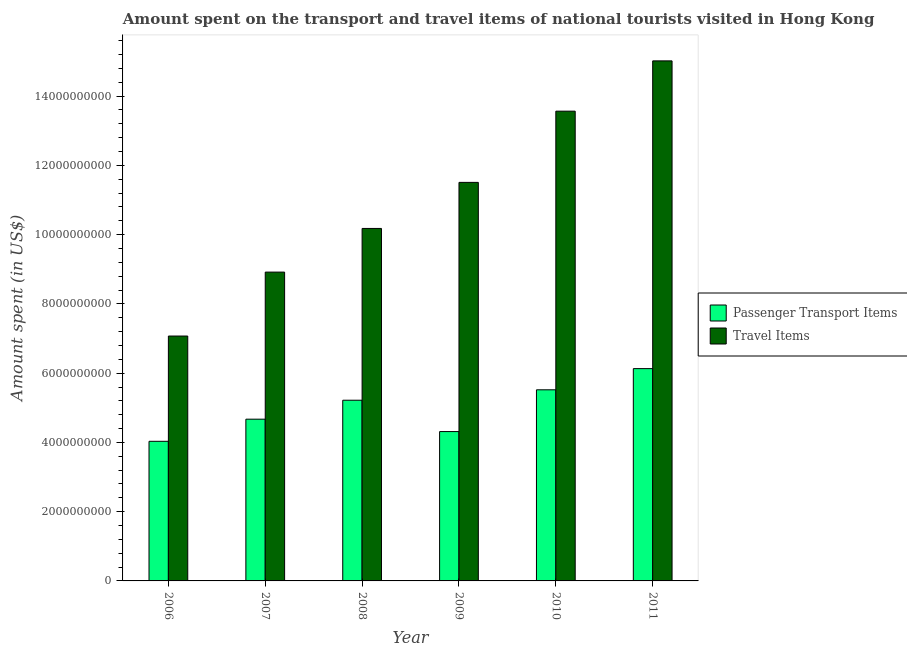Are the number of bars per tick equal to the number of legend labels?
Offer a terse response. Yes. What is the label of the 2nd group of bars from the left?
Make the answer very short. 2007. In how many cases, is the number of bars for a given year not equal to the number of legend labels?
Ensure brevity in your answer.  0. What is the amount spent on passenger transport items in 2007?
Provide a succinct answer. 4.67e+09. Across all years, what is the maximum amount spent in travel items?
Provide a succinct answer. 1.50e+1. Across all years, what is the minimum amount spent in travel items?
Provide a succinct answer. 7.07e+09. What is the total amount spent in travel items in the graph?
Your answer should be very brief. 6.63e+1. What is the difference between the amount spent in travel items in 2008 and that in 2011?
Ensure brevity in your answer.  -4.84e+09. What is the difference between the amount spent on passenger transport items in 2006 and the amount spent in travel items in 2008?
Keep it short and to the point. -1.19e+09. What is the average amount spent on passenger transport items per year?
Your answer should be compact. 4.98e+09. In how many years, is the amount spent in travel items greater than 11600000000 US$?
Your answer should be very brief. 2. What is the ratio of the amount spent in travel items in 2009 to that in 2011?
Offer a terse response. 0.77. What is the difference between the highest and the second highest amount spent on passenger transport items?
Your response must be concise. 6.12e+08. What is the difference between the highest and the lowest amount spent on passenger transport items?
Keep it short and to the point. 2.10e+09. What does the 1st bar from the left in 2009 represents?
Provide a succinct answer. Passenger Transport Items. What does the 2nd bar from the right in 2007 represents?
Offer a very short reply. Passenger Transport Items. Are all the bars in the graph horizontal?
Keep it short and to the point. No. How many years are there in the graph?
Keep it short and to the point. 6. Does the graph contain any zero values?
Keep it short and to the point. No. Does the graph contain grids?
Provide a succinct answer. No. Where does the legend appear in the graph?
Give a very brief answer. Center right. How are the legend labels stacked?
Your answer should be very brief. Vertical. What is the title of the graph?
Your answer should be very brief. Amount spent on the transport and travel items of national tourists visited in Hong Kong. Does "Primary school" appear as one of the legend labels in the graph?
Your answer should be compact. No. What is the label or title of the X-axis?
Make the answer very short. Year. What is the label or title of the Y-axis?
Your answer should be very brief. Amount spent (in US$). What is the Amount spent (in US$) of Passenger Transport Items in 2006?
Your response must be concise. 4.03e+09. What is the Amount spent (in US$) of Travel Items in 2006?
Make the answer very short. 7.07e+09. What is the Amount spent (in US$) of Passenger Transport Items in 2007?
Offer a very short reply. 4.67e+09. What is the Amount spent (in US$) of Travel Items in 2007?
Keep it short and to the point. 8.92e+09. What is the Amount spent (in US$) in Passenger Transport Items in 2008?
Offer a terse response. 5.22e+09. What is the Amount spent (in US$) of Travel Items in 2008?
Your answer should be very brief. 1.02e+1. What is the Amount spent (in US$) in Passenger Transport Items in 2009?
Your response must be concise. 4.31e+09. What is the Amount spent (in US$) in Travel Items in 2009?
Provide a short and direct response. 1.15e+1. What is the Amount spent (in US$) of Passenger Transport Items in 2010?
Give a very brief answer. 5.52e+09. What is the Amount spent (in US$) in Travel Items in 2010?
Your response must be concise. 1.36e+1. What is the Amount spent (in US$) in Passenger Transport Items in 2011?
Offer a terse response. 6.13e+09. What is the Amount spent (in US$) in Travel Items in 2011?
Your answer should be compact. 1.50e+1. Across all years, what is the maximum Amount spent (in US$) in Passenger Transport Items?
Provide a succinct answer. 6.13e+09. Across all years, what is the maximum Amount spent (in US$) in Travel Items?
Offer a terse response. 1.50e+1. Across all years, what is the minimum Amount spent (in US$) of Passenger Transport Items?
Offer a terse response. 4.03e+09. Across all years, what is the minimum Amount spent (in US$) of Travel Items?
Offer a terse response. 7.07e+09. What is the total Amount spent (in US$) in Passenger Transport Items in the graph?
Your response must be concise. 2.99e+1. What is the total Amount spent (in US$) in Travel Items in the graph?
Give a very brief answer. 6.63e+1. What is the difference between the Amount spent (in US$) of Passenger Transport Items in 2006 and that in 2007?
Offer a terse response. -6.39e+08. What is the difference between the Amount spent (in US$) of Travel Items in 2006 and that in 2007?
Provide a short and direct response. -1.85e+09. What is the difference between the Amount spent (in US$) of Passenger Transport Items in 2006 and that in 2008?
Give a very brief answer. -1.19e+09. What is the difference between the Amount spent (in US$) in Travel Items in 2006 and that in 2008?
Offer a terse response. -3.11e+09. What is the difference between the Amount spent (in US$) in Passenger Transport Items in 2006 and that in 2009?
Give a very brief answer. -2.81e+08. What is the difference between the Amount spent (in US$) in Travel Items in 2006 and that in 2009?
Keep it short and to the point. -4.44e+09. What is the difference between the Amount spent (in US$) of Passenger Transport Items in 2006 and that in 2010?
Keep it short and to the point. -1.49e+09. What is the difference between the Amount spent (in US$) of Travel Items in 2006 and that in 2010?
Give a very brief answer. -6.49e+09. What is the difference between the Amount spent (in US$) of Passenger Transport Items in 2006 and that in 2011?
Keep it short and to the point. -2.10e+09. What is the difference between the Amount spent (in US$) of Travel Items in 2006 and that in 2011?
Provide a succinct answer. -7.95e+09. What is the difference between the Amount spent (in US$) of Passenger Transport Items in 2007 and that in 2008?
Your response must be concise. -5.47e+08. What is the difference between the Amount spent (in US$) in Travel Items in 2007 and that in 2008?
Keep it short and to the point. -1.26e+09. What is the difference between the Amount spent (in US$) of Passenger Transport Items in 2007 and that in 2009?
Your response must be concise. 3.58e+08. What is the difference between the Amount spent (in US$) in Travel Items in 2007 and that in 2009?
Your answer should be very brief. -2.59e+09. What is the difference between the Amount spent (in US$) in Passenger Transport Items in 2007 and that in 2010?
Give a very brief answer. -8.48e+08. What is the difference between the Amount spent (in US$) in Travel Items in 2007 and that in 2010?
Your answer should be very brief. -4.65e+09. What is the difference between the Amount spent (in US$) in Passenger Transport Items in 2007 and that in 2011?
Ensure brevity in your answer.  -1.46e+09. What is the difference between the Amount spent (in US$) in Travel Items in 2007 and that in 2011?
Your answer should be very brief. -6.10e+09. What is the difference between the Amount spent (in US$) in Passenger Transport Items in 2008 and that in 2009?
Offer a terse response. 9.05e+08. What is the difference between the Amount spent (in US$) in Travel Items in 2008 and that in 2009?
Provide a succinct answer. -1.33e+09. What is the difference between the Amount spent (in US$) in Passenger Transport Items in 2008 and that in 2010?
Provide a short and direct response. -3.01e+08. What is the difference between the Amount spent (in US$) of Travel Items in 2008 and that in 2010?
Your answer should be very brief. -3.39e+09. What is the difference between the Amount spent (in US$) of Passenger Transport Items in 2008 and that in 2011?
Ensure brevity in your answer.  -9.13e+08. What is the difference between the Amount spent (in US$) of Travel Items in 2008 and that in 2011?
Ensure brevity in your answer.  -4.84e+09. What is the difference between the Amount spent (in US$) of Passenger Transport Items in 2009 and that in 2010?
Give a very brief answer. -1.21e+09. What is the difference between the Amount spent (in US$) in Travel Items in 2009 and that in 2010?
Give a very brief answer. -2.06e+09. What is the difference between the Amount spent (in US$) in Passenger Transport Items in 2009 and that in 2011?
Provide a succinct answer. -1.82e+09. What is the difference between the Amount spent (in US$) of Travel Items in 2009 and that in 2011?
Give a very brief answer. -3.51e+09. What is the difference between the Amount spent (in US$) of Passenger Transport Items in 2010 and that in 2011?
Offer a terse response. -6.12e+08. What is the difference between the Amount spent (in US$) of Travel Items in 2010 and that in 2011?
Provide a succinct answer. -1.45e+09. What is the difference between the Amount spent (in US$) in Passenger Transport Items in 2006 and the Amount spent (in US$) in Travel Items in 2007?
Offer a terse response. -4.89e+09. What is the difference between the Amount spent (in US$) in Passenger Transport Items in 2006 and the Amount spent (in US$) in Travel Items in 2008?
Your answer should be very brief. -6.15e+09. What is the difference between the Amount spent (in US$) of Passenger Transport Items in 2006 and the Amount spent (in US$) of Travel Items in 2009?
Your answer should be very brief. -7.48e+09. What is the difference between the Amount spent (in US$) of Passenger Transport Items in 2006 and the Amount spent (in US$) of Travel Items in 2010?
Ensure brevity in your answer.  -9.53e+09. What is the difference between the Amount spent (in US$) in Passenger Transport Items in 2006 and the Amount spent (in US$) in Travel Items in 2011?
Offer a terse response. -1.10e+1. What is the difference between the Amount spent (in US$) in Passenger Transport Items in 2007 and the Amount spent (in US$) in Travel Items in 2008?
Provide a short and direct response. -5.51e+09. What is the difference between the Amount spent (in US$) of Passenger Transport Items in 2007 and the Amount spent (in US$) of Travel Items in 2009?
Provide a short and direct response. -6.84e+09. What is the difference between the Amount spent (in US$) of Passenger Transport Items in 2007 and the Amount spent (in US$) of Travel Items in 2010?
Give a very brief answer. -8.90e+09. What is the difference between the Amount spent (in US$) in Passenger Transport Items in 2007 and the Amount spent (in US$) in Travel Items in 2011?
Your response must be concise. -1.03e+1. What is the difference between the Amount spent (in US$) in Passenger Transport Items in 2008 and the Amount spent (in US$) in Travel Items in 2009?
Keep it short and to the point. -6.29e+09. What is the difference between the Amount spent (in US$) of Passenger Transport Items in 2008 and the Amount spent (in US$) of Travel Items in 2010?
Provide a succinct answer. -8.35e+09. What is the difference between the Amount spent (in US$) in Passenger Transport Items in 2008 and the Amount spent (in US$) in Travel Items in 2011?
Your answer should be compact. -9.80e+09. What is the difference between the Amount spent (in US$) of Passenger Transport Items in 2009 and the Amount spent (in US$) of Travel Items in 2010?
Ensure brevity in your answer.  -9.25e+09. What is the difference between the Amount spent (in US$) in Passenger Transport Items in 2009 and the Amount spent (in US$) in Travel Items in 2011?
Ensure brevity in your answer.  -1.07e+1. What is the difference between the Amount spent (in US$) of Passenger Transport Items in 2010 and the Amount spent (in US$) of Travel Items in 2011?
Offer a very short reply. -9.50e+09. What is the average Amount spent (in US$) in Passenger Transport Items per year?
Provide a short and direct response. 4.98e+09. What is the average Amount spent (in US$) in Travel Items per year?
Provide a short and direct response. 1.10e+1. In the year 2006, what is the difference between the Amount spent (in US$) in Passenger Transport Items and Amount spent (in US$) in Travel Items?
Keep it short and to the point. -3.04e+09. In the year 2007, what is the difference between the Amount spent (in US$) in Passenger Transport Items and Amount spent (in US$) in Travel Items?
Make the answer very short. -4.25e+09. In the year 2008, what is the difference between the Amount spent (in US$) in Passenger Transport Items and Amount spent (in US$) in Travel Items?
Ensure brevity in your answer.  -4.96e+09. In the year 2009, what is the difference between the Amount spent (in US$) of Passenger Transport Items and Amount spent (in US$) of Travel Items?
Your answer should be very brief. -7.20e+09. In the year 2010, what is the difference between the Amount spent (in US$) of Passenger Transport Items and Amount spent (in US$) of Travel Items?
Your answer should be very brief. -8.05e+09. In the year 2011, what is the difference between the Amount spent (in US$) of Passenger Transport Items and Amount spent (in US$) of Travel Items?
Provide a succinct answer. -8.89e+09. What is the ratio of the Amount spent (in US$) of Passenger Transport Items in 2006 to that in 2007?
Your response must be concise. 0.86. What is the ratio of the Amount spent (in US$) of Travel Items in 2006 to that in 2007?
Your answer should be compact. 0.79. What is the ratio of the Amount spent (in US$) of Passenger Transport Items in 2006 to that in 2008?
Give a very brief answer. 0.77. What is the ratio of the Amount spent (in US$) of Travel Items in 2006 to that in 2008?
Your answer should be compact. 0.69. What is the ratio of the Amount spent (in US$) of Passenger Transport Items in 2006 to that in 2009?
Offer a very short reply. 0.93. What is the ratio of the Amount spent (in US$) in Travel Items in 2006 to that in 2009?
Keep it short and to the point. 0.61. What is the ratio of the Amount spent (in US$) of Passenger Transport Items in 2006 to that in 2010?
Your response must be concise. 0.73. What is the ratio of the Amount spent (in US$) of Travel Items in 2006 to that in 2010?
Your answer should be very brief. 0.52. What is the ratio of the Amount spent (in US$) in Passenger Transport Items in 2006 to that in 2011?
Give a very brief answer. 0.66. What is the ratio of the Amount spent (in US$) of Travel Items in 2006 to that in 2011?
Give a very brief answer. 0.47. What is the ratio of the Amount spent (in US$) in Passenger Transport Items in 2007 to that in 2008?
Keep it short and to the point. 0.9. What is the ratio of the Amount spent (in US$) in Travel Items in 2007 to that in 2008?
Your answer should be very brief. 0.88. What is the ratio of the Amount spent (in US$) in Passenger Transport Items in 2007 to that in 2009?
Provide a short and direct response. 1.08. What is the ratio of the Amount spent (in US$) in Travel Items in 2007 to that in 2009?
Provide a succinct answer. 0.77. What is the ratio of the Amount spent (in US$) of Passenger Transport Items in 2007 to that in 2010?
Give a very brief answer. 0.85. What is the ratio of the Amount spent (in US$) of Travel Items in 2007 to that in 2010?
Your answer should be compact. 0.66. What is the ratio of the Amount spent (in US$) in Passenger Transport Items in 2007 to that in 2011?
Offer a terse response. 0.76. What is the ratio of the Amount spent (in US$) in Travel Items in 2007 to that in 2011?
Your answer should be very brief. 0.59. What is the ratio of the Amount spent (in US$) of Passenger Transport Items in 2008 to that in 2009?
Your answer should be compact. 1.21. What is the ratio of the Amount spent (in US$) of Travel Items in 2008 to that in 2009?
Make the answer very short. 0.88. What is the ratio of the Amount spent (in US$) of Passenger Transport Items in 2008 to that in 2010?
Provide a succinct answer. 0.95. What is the ratio of the Amount spent (in US$) in Travel Items in 2008 to that in 2010?
Offer a terse response. 0.75. What is the ratio of the Amount spent (in US$) of Passenger Transport Items in 2008 to that in 2011?
Offer a very short reply. 0.85. What is the ratio of the Amount spent (in US$) of Travel Items in 2008 to that in 2011?
Keep it short and to the point. 0.68. What is the ratio of the Amount spent (in US$) of Passenger Transport Items in 2009 to that in 2010?
Make the answer very short. 0.78. What is the ratio of the Amount spent (in US$) of Travel Items in 2009 to that in 2010?
Ensure brevity in your answer.  0.85. What is the ratio of the Amount spent (in US$) in Passenger Transport Items in 2009 to that in 2011?
Your answer should be compact. 0.7. What is the ratio of the Amount spent (in US$) in Travel Items in 2009 to that in 2011?
Make the answer very short. 0.77. What is the ratio of the Amount spent (in US$) in Passenger Transport Items in 2010 to that in 2011?
Ensure brevity in your answer.  0.9. What is the ratio of the Amount spent (in US$) of Travel Items in 2010 to that in 2011?
Your response must be concise. 0.9. What is the difference between the highest and the second highest Amount spent (in US$) in Passenger Transport Items?
Your answer should be very brief. 6.12e+08. What is the difference between the highest and the second highest Amount spent (in US$) in Travel Items?
Ensure brevity in your answer.  1.45e+09. What is the difference between the highest and the lowest Amount spent (in US$) in Passenger Transport Items?
Keep it short and to the point. 2.10e+09. What is the difference between the highest and the lowest Amount spent (in US$) in Travel Items?
Your response must be concise. 7.95e+09. 